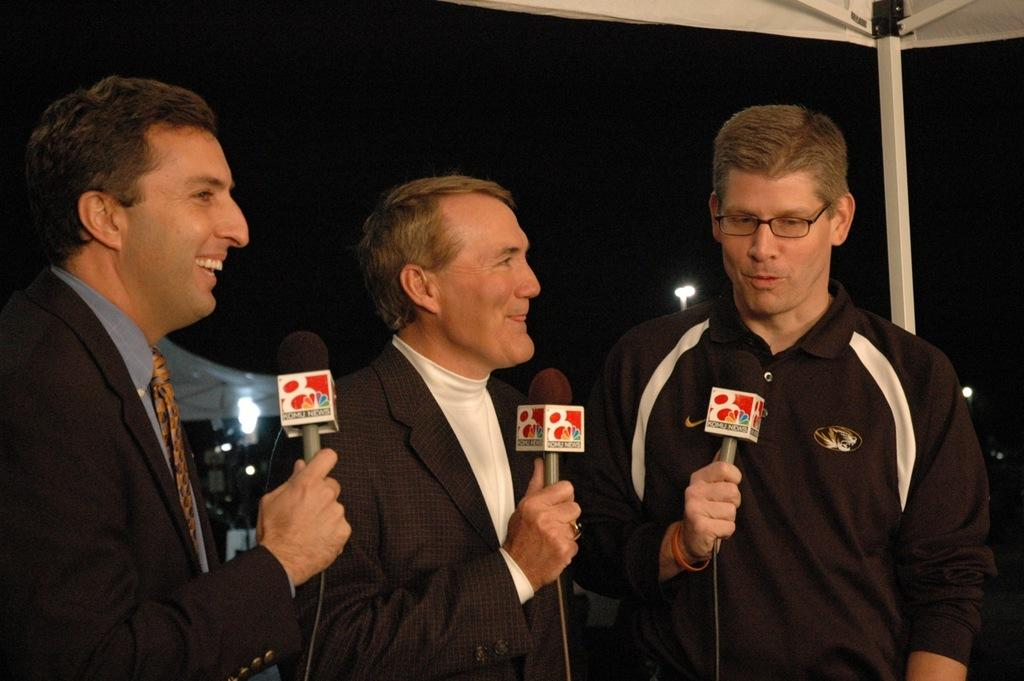How many men are in the image? There are three men in the image. What are the men doing in the image? The men are standing and holding microphones. Can you describe the expressions of the people in the image? There are people with smiles in the image. Is there anyone in the image wearing glasses? Yes, one person is wearing glasses. What type of jewel can be seen falling from the sky during the rainstorm in the image? There is no rainstorm or jewel present in the image. 